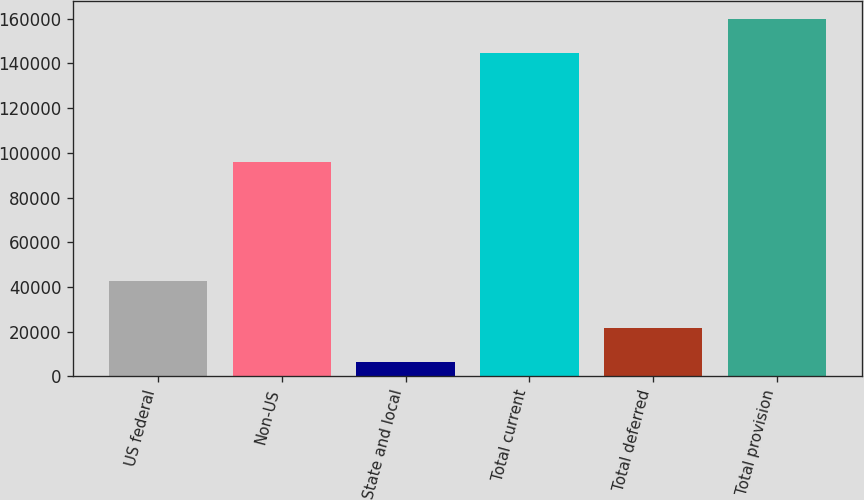Convert chart. <chart><loc_0><loc_0><loc_500><loc_500><bar_chart><fcel>US federal<fcel>Non-US<fcel>State and local<fcel>Total current<fcel>Total deferred<fcel>Total provision<nl><fcel>42596<fcel>95677<fcel>6567<fcel>144840<fcel>21762.7<fcel>160036<nl></chart> 